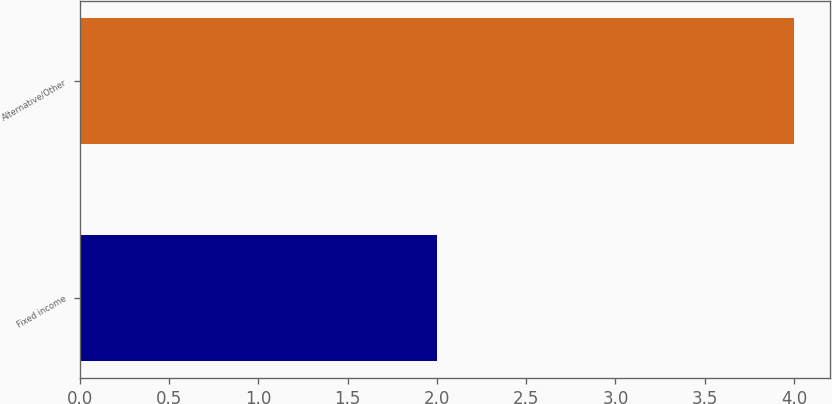Convert chart to OTSL. <chart><loc_0><loc_0><loc_500><loc_500><bar_chart><fcel>Fixed income<fcel>Alternative/Other<nl><fcel>2<fcel>4<nl></chart> 